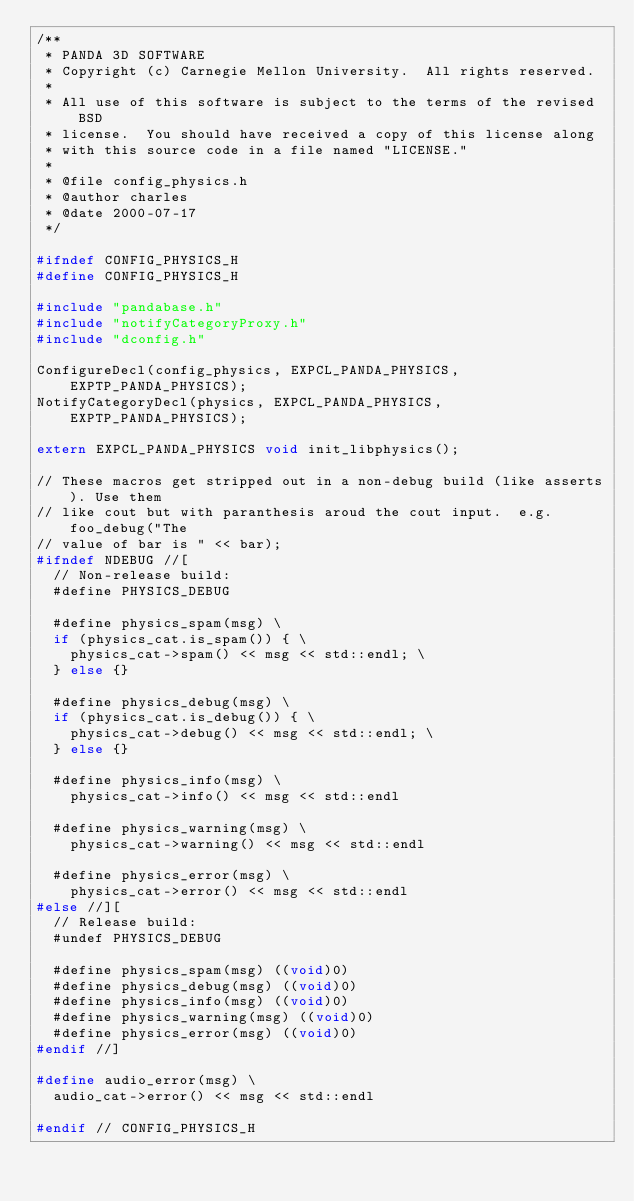Convert code to text. <code><loc_0><loc_0><loc_500><loc_500><_C_>/**
 * PANDA 3D SOFTWARE
 * Copyright (c) Carnegie Mellon University.  All rights reserved.
 *
 * All use of this software is subject to the terms of the revised BSD
 * license.  You should have received a copy of this license along
 * with this source code in a file named "LICENSE."
 *
 * @file config_physics.h
 * @author charles
 * @date 2000-07-17
 */

#ifndef CONFIG_PHYSICS_H
#define CONFIG_PHYSICS_H

#include "pandabase.h"
#include "notifyCategoryProxy.h"
#include "dconfig.h"

ConfigureDecl(config_physics, EXPCL_PANDA_PHYSICS, EXPTP_PANDA_PHYSICS);
NotifyCategoryDecl(physics, EXPCL_PANDA_PHYSICS, EXPTP_PANDA_PHYSICS);

extern EXPCL_PANDA_PHYSICS void init_libphysics();

// These macros get stripped out in a non-debug build (like asserts). Use them
// like cout but with paranthesis aroud the cout input.  e.g.  foo_debug("The
// value of bar is " << bar);
#ifndef NDEBUG //[
  // Non-release build:
  #define PHYSICS_DEBUG

  #define physics_spam(msg) \
  if (physics_cat.is_spam()) { \
    physics_cat->spam() << msg << std::endl; \
  } else {}

  #define physics_debug(msg) \
  if (physics_cat.is_debug()) { \
    physics_cat->debug() << msg << std::endl; \
  } else {}

  #define physics_info(msg) \
    physics_cat->info() << msg << std::endl

  #define physics_warning(msg) \
    physics_cat->warning() << msg << std::endl

  #define physics_error(msg) \
    physics_cat->error() << msg << std::endl
#else //][
  // Release build:
  #undef PHYSICS_DEBUG

  #define physics_spam(msg) ((void)0)
  #define physics_debug(msg) ((void)0)
  #define physics_info(msg) ((void)0)
  #define physics_warning(msg) ((void)0)
  #define physics_error(msg) ((void)0)
#endif //]

#define audio_error(msg) \
  audio_cat->error() << msg << std::endl

#endif // CONFIG_PHYSICS_H
</code> 